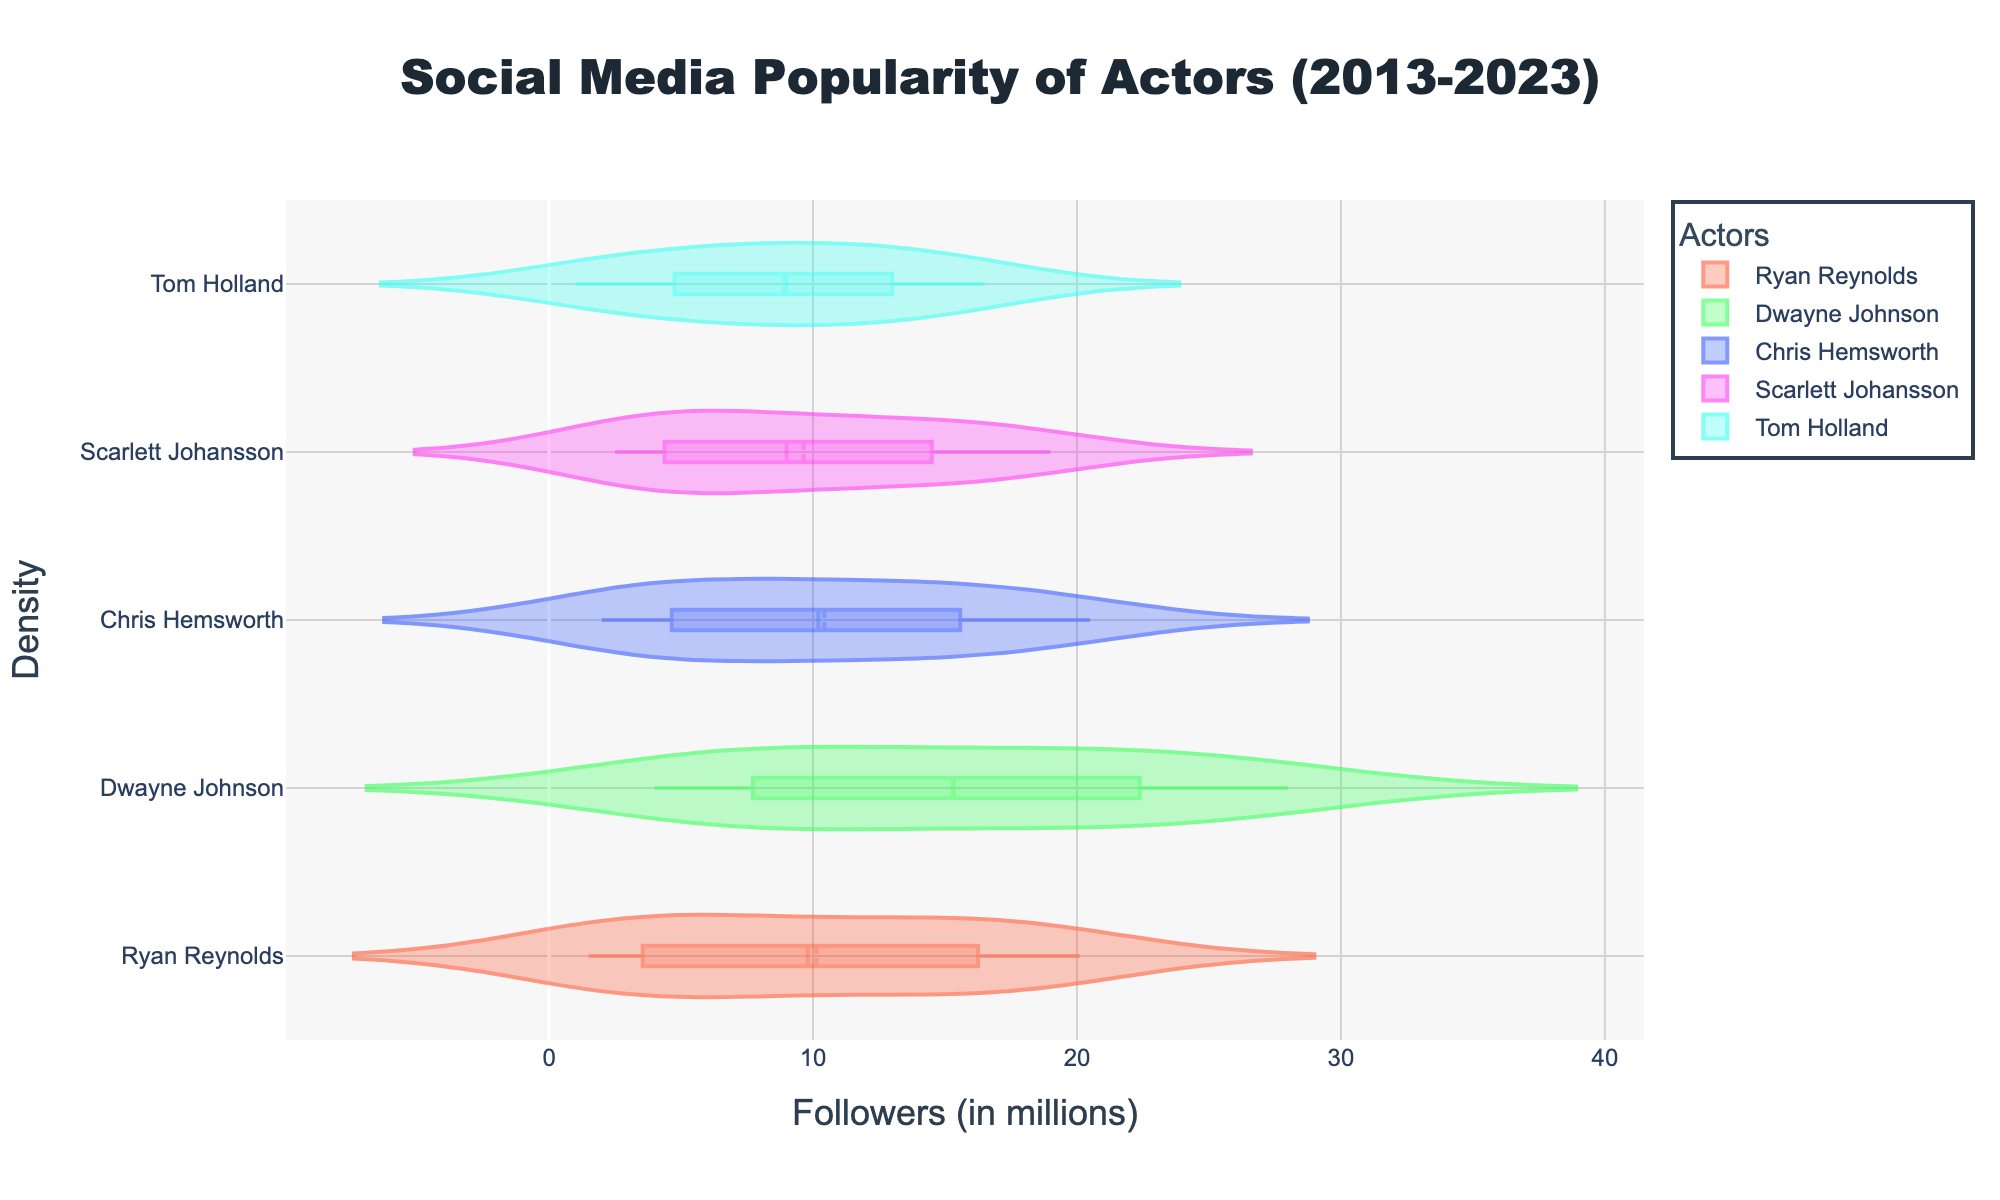What is the title of the figure? The title is located at the top center of the figure. It is usually concise and descriptive, summarizing the content of the plot.
Answer: Social Media Popularity of Actors (2013-2023) What are the axis titles in the figure? The x-axis title and y-axis title are displayed below and to the left of the plot area, respectively. They describe what each axis represents.
Answer: The x-axis is titled "Followers (in millions)" and the y-axis is titled "Density" Which actor has the highest peak density in the plot? The highest peak density is the tallest point on the y-axis corresponding to the x-axis value for any actor.
Answer: Dwayne Johnson What is the color of Ryan Reynolds' violin plot? Each violin plot is colored distinctly for easy identification. Ryan Reynolds' plot would be identified by its color.
Answer: #FF5733 (a shade of orange) Between 2018 and 2023, whose follower count increased more, Chris Hemsworth or Scarlett Johansson? Compare the increase in number of followers for Chris Hemsworth and Scarlett Johansson from 2018 to 2023 by subtracting their 2018 followers from their 2023 followers and then comparing the differences.
Answer: Scarlett Johansson Who had the lowest number of followers in 2016? The violin plots represent density of number of followers for each actor over the years. Looking at the 2016 data points allows us to determine the actor with the lowest followers.
Answer: Tom Holland Whose follower trend shows a steep increase between 2015 and 2016? A steep increase can be identified by comparing the followers data from 2015 to 2016 for each actor and observing the plot shapes. The actor with the most noticeable rise has the steepest increase.
Answer: Ryan Reynolds Which actor had the most consistent increase in followers over the last decade? Consistency in increase would appear as a steadily rising line without sudden jumps or dips. Look for the actor with a comparatively smooth and steady rise in their followers count.
Answer: Chris Hemsworth In 2020, did Ryan Reynolds have more followers than Tom Holland? Compare Ryan Reynolds' and Tom Holland's followers count in the year 2020 from the violin plots.
Answer: Yes Comparing the mean follower counts, whose mean is higher, Ryan Reynolds or Scarlett Johansson? Violin plots with visible mean lines (shown as dashed lines) help to compare the average follower counts directly. Identify the mean lines for Ryan Reynolds and Scarlett Johansson and compare their positions.
Answer: Scarlett Johansson 